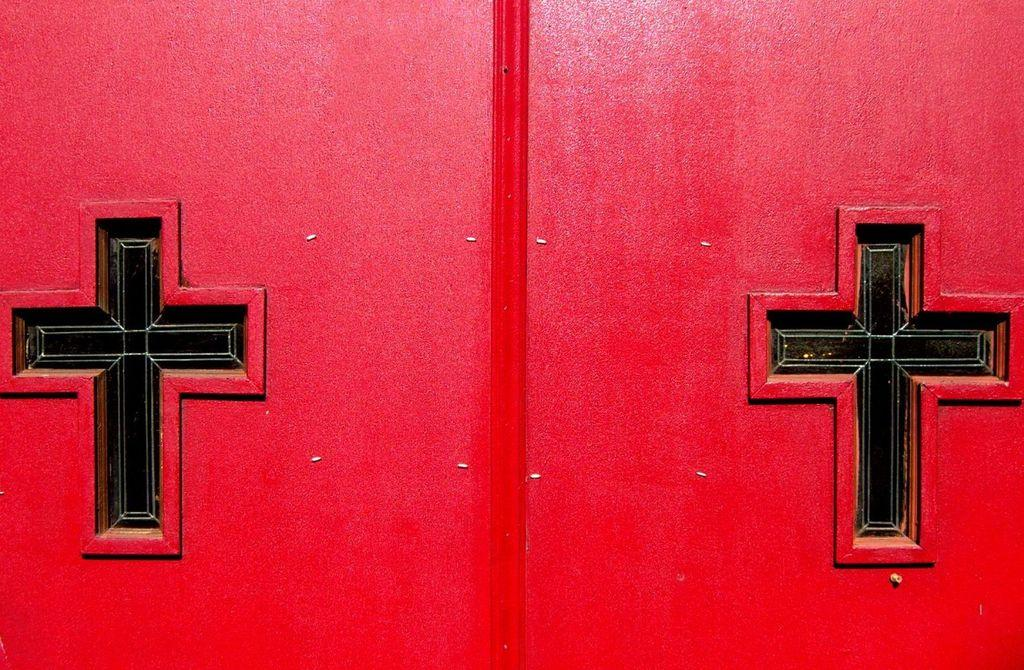What is on the red wall in the image? There are two cross marks on a red wall in the image. What object is in the middle of the image? There is a wooden stick in the middle of the image. How many cakes are on the wooden stick in the image? There are no cakes present in the image; it only features a wooden stick and cross marks on a red wall. 